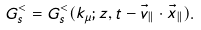Convert formula to latex. <formula><loc_0><loc_0><loc_500><loc_500>G _ { s } ^ { < } = G _ { s } ^ { < } ( k _ { \mu } ; z , t - \vec { v } _ { \| } \cdot \vec { x } _ { \| } ) .</formula> 